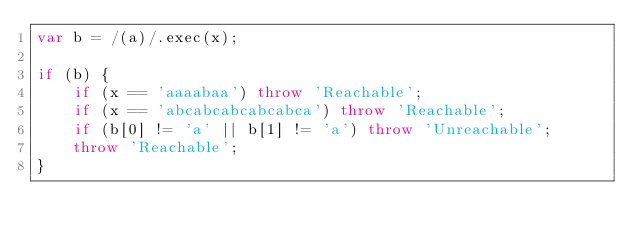Convert code to text. <code><loc_0><loc_0><loc_500><loc_500><_JavaScript_>var b = /(a)/.exec(x);

if (b) {
	if (x == 'aaaabaa') throw 'Reachable';
	if (x == 'abcabcabcabcabca') throw 'Reachable';
	if (b[0] != 'a' || b[1] != 'a') throw 'Unreachable';
	throw 'Reachable';
}
</code> 